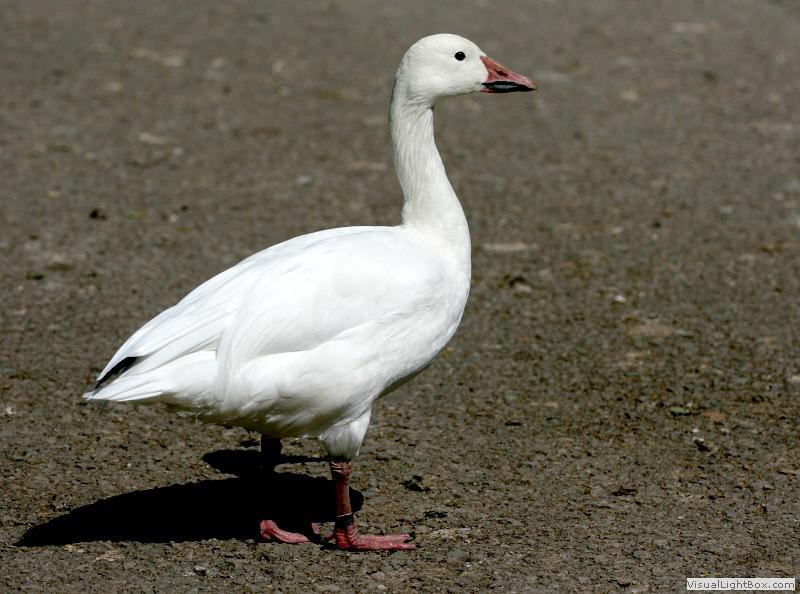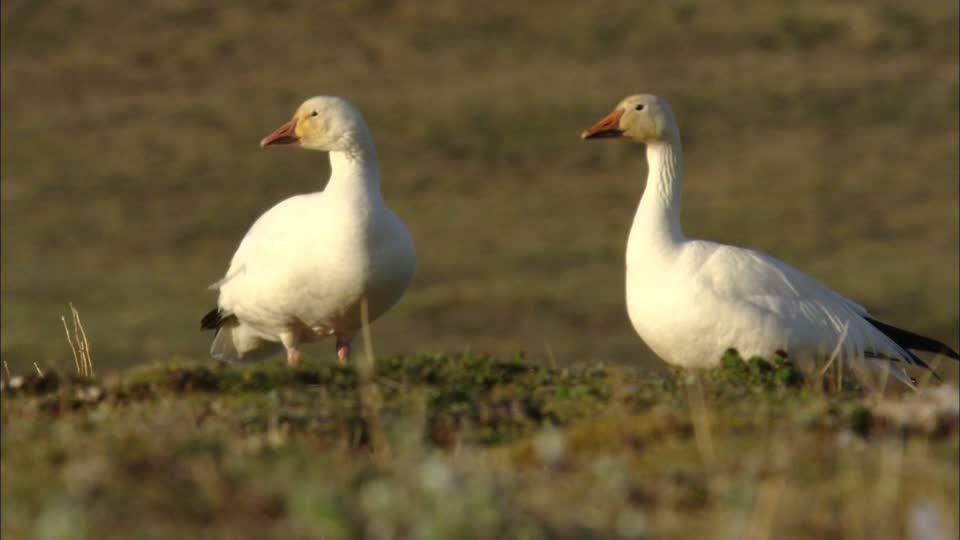The first image is the image on the left, the second image is the image on the right. For the images displayed, is the sentence "All the geese have completely white heads." factually correct? Answer yes or no. Yes. 